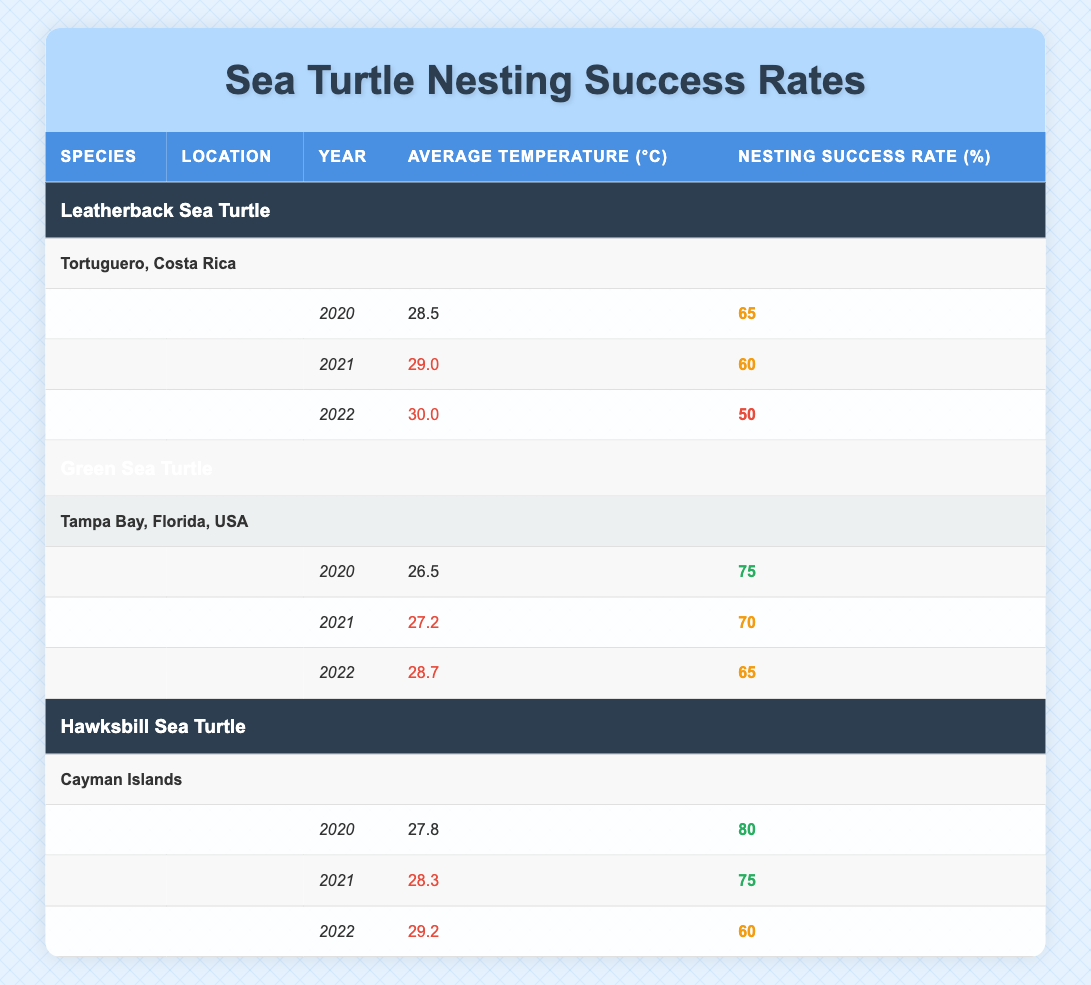What was the nesting success rate of the Hawksbill Sea Turtle in 2020? Referring to the table, in the year 2020, the Hawksbill Sea Turtle had a nesting success rate of 80% at the Cayman Islands location.
Answer: 80% Which sea turtle species had the highest average temperature in 2022? In 2022, the average temperatures were: Leatherback Sea Turtle 30.0°C, Green Sea Turtle 28.7°C, and Hawksbill Sea Turtle 29.2°C. The Leatherback Sea Turtle had the highest average temperature.
Answer: Leatherback Sea Turtle Was the nesting success rate for the Green Sea Turtle consistent over the three years? Checking the nesting success rates for the Green Sea Turtle: 75% in 2020, 70% in 2021, and 65% in 2022. The rates decreased each year, indicating inconsistency.
Answer: No Calculate the average nesting success rate for the Leatherback Sea Turtle from 2020 to 2022. The nesting success rates for the Leatherback Sea Turtle are 65% (2020), 60% (2021), and 50% (2022). Adding these gives 65 + 60 + 50 = 175, and dividing by 3 gives an average of 175/3 = 58.33%.
Answer: 58.33% Which turtle species had the lowest nesting success rate in 2022? For 2022, the nesting success rates were: Leatherback Sea Turtle 50%, Green Sea Turtle 65%, and Hawksbill Sea Turtle 60%. The Leatherback Sea Turtle had the lowest rate.
Answer: Leatherback Sea Turtle What was the temperature change from 2020 to 2022 for the Green Sea Turtle? The average temperatures for the Green Sea Turtle for 2020, 2021, and 2022 are 26.5°C, 27.2°C, and 28.7°C respectively. The difference from 2020 to 2022 is 28.7 - 26.5 = 2.2°C.
Answer: 2.2°C Was the average temperature for the Hawksbill Sea Turtle in 2021 higher than the temperature in 2020? The average temperature for the Hawksbill Sea Turtle was 27.8°C in 2020 and 28.3°C in 2021. Since 28.3°C is higher than 27.8°C, the answer is yes.
Answer: Yes What was the overall trend in nesting success rates for the Leatherback Sea Turtle from 2020 to 2022? The nesting success rates for the Leatherback Sea Turtle decreased from 65% in 2020 to 60% in 2021, and then to 50% in 2022, indicating a declining trend over the years.
Answer: Declining trend 